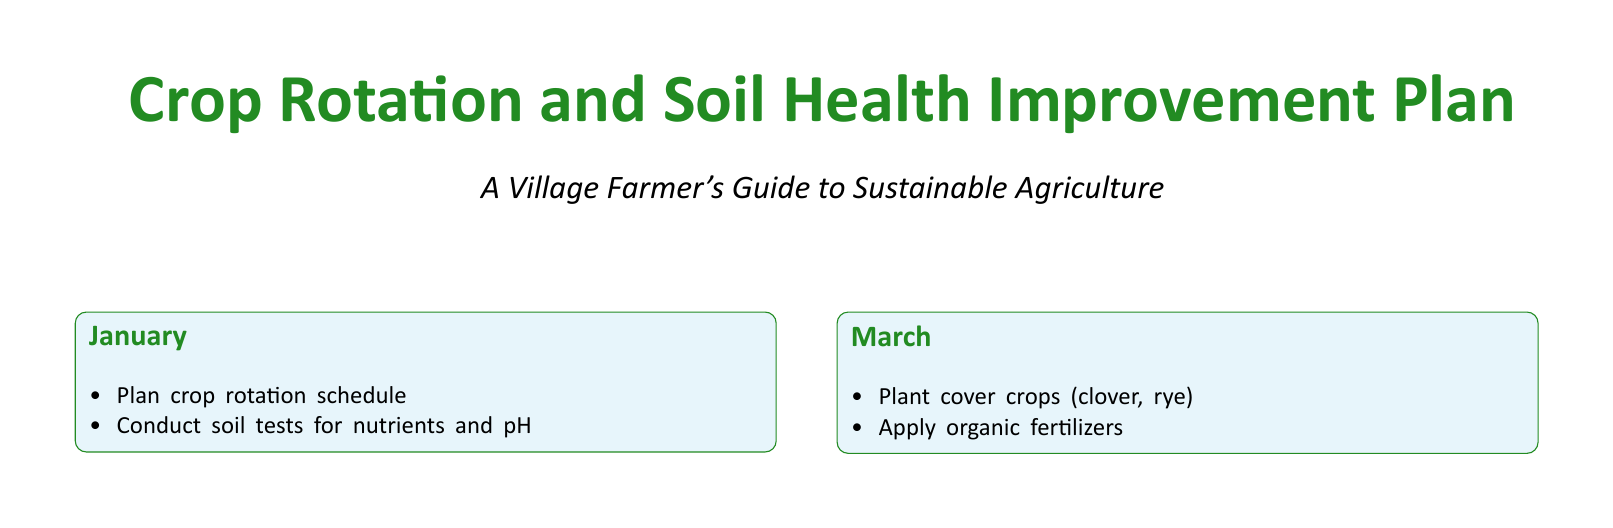What is planned in January? The document specifies activities for January, which include planning the crop rotation schedule and conducting soil tests for nutrients and pH.
Answer: Crop rotation schedule, soil tests What crops are recommended to be planted in March? According to the document, cover crops such as clover and rye should be planted in March.
Answer: Clover, rye What are the primary crops to plant in May? The primary crops mentioned for May are maize and wheat, as noted in the document.
Answer: Maize, wheat Which month is designated for managing soil moisture? The document indicates that July is the month for managing soil moisture in the farming activities.
Answer: July What activity should be conducted in September? In September, the document states that the crops should be harvested and assessed for yield.
Answer: Harvest crops, assess yield What should be added to the soil if needed in November? The document suggests that lime or gypsum may need to be added to the soil in November.
Answer: Lime, gypsum Why is improving soil health important according to the farmer's note? The farmer's note emphasizes that improving soil health is crucial for sustainable farming practices.
Answer: Sustainable farming Which crops are to be monitored in May? The document notes that insect pollinators should be monitored in May.
Answer: Insect pollinators What is the overall goal of the Crop Rotation and Soil Health Improvement Plan? The overarching goal highlighted in the document is to enhance soil fertility and productivity.
Answer: Enhance soil fertility, productivity 